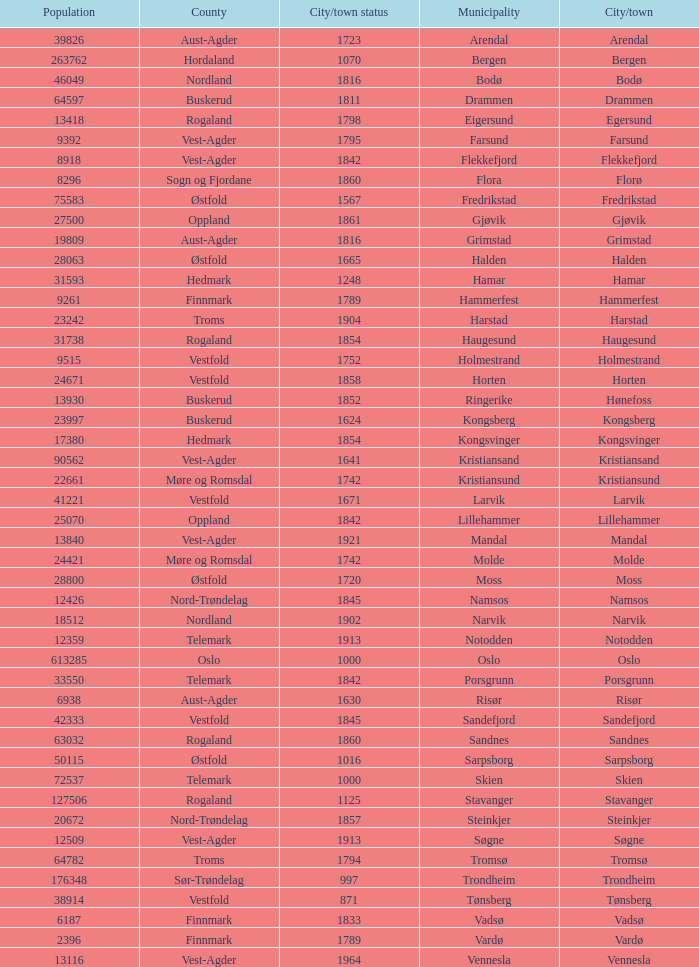Which municipalities located in the county of Finnmark have populations bigger than 6187.0? Hammerfest. 